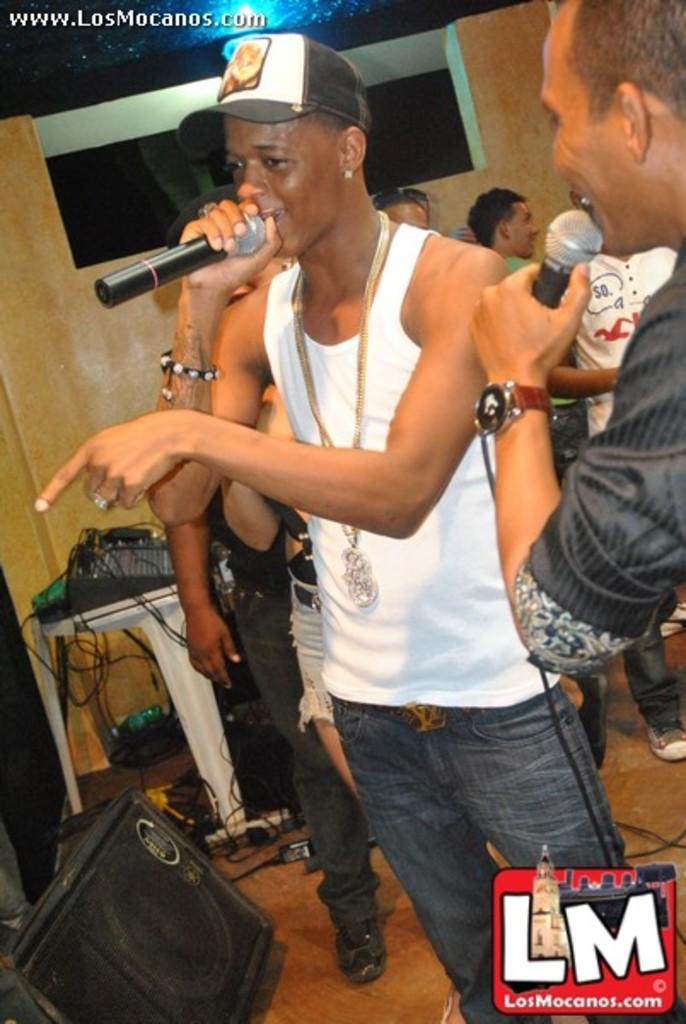How many people are in the image? There are two people in the image. What are the people holding in the image? The people are holding miles in the image. Where are the people standing in the image? The people are standing on the floor in the image. What can be seen near the people in the image? There is a speaker visible in the image. What else is present in the image besides the people and the speaker? There is a table with wires and clothes in the image, and there is a wall in the image. What type of chess piece is visible on the table in the image? There is no chess piece visible on the table in the image; it contains wires and clothes. How many icicles can be seen hanging from the wall in the image? There are no icicles present in the image; it features a wall without any icicles. 